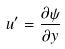<formula> <loc_0><loc_0><loc_500><loc_500>u ^ { \prime } = \frac { \partial \psi } { \partial y }</formula> 